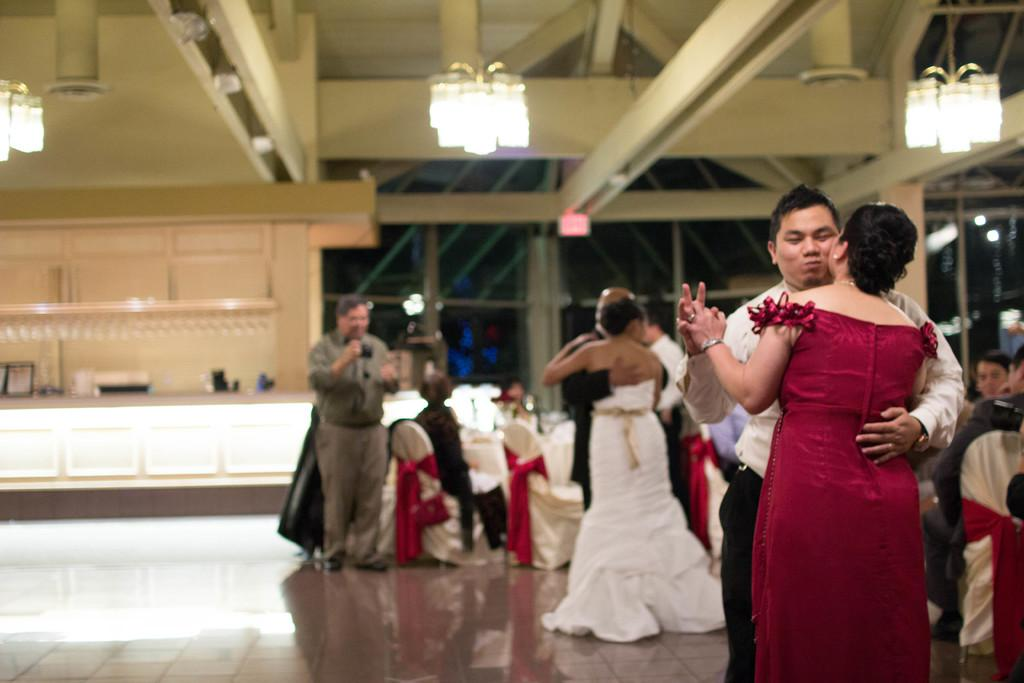What are the people in the image doing? There are people standing on the floor and sitting on chairs in the image. What can be seen in the background of the image? There is a chandelier and grills in the background of the image. What type of cherry is being used to decorate the iron in the image? There is no cherry or iron present in the image. What suggestion is being made by the people in the image? The image does not depict any suggestions being made by the people. 